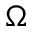<formula> <loc_0><loc_0><loc_500><loc_500>\Omega</formula> 